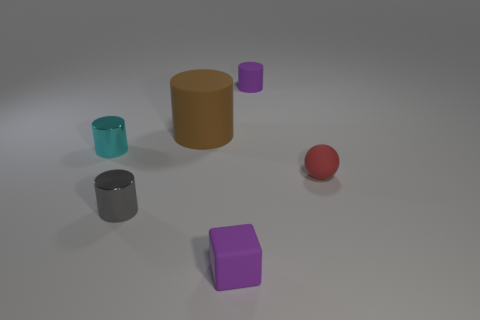Subtract all tiny cylinders. How many cylinders are left? 1 Subtract 1 spheres. How many spheres are left? 0 Add 2 big green shiny cylinders. How many objects exist? 8 Subtract all gray cylinders. How many cylinders are left? 3 Subtract all cylinders. How many objects are left? 2 Subtract all small matte blocks. Subtract all large brown matte cylinders. How many objects are left? 4 Add 6 gray metal objects. How many gray metal objects are left? 7 Add 4 red matte things. How many red matte things exist? 5 Subtract 0 brown balls. How many objects are left? 6 Subtract all green cubes. Subtract all purple cylinders. How many cubes are left? 1 